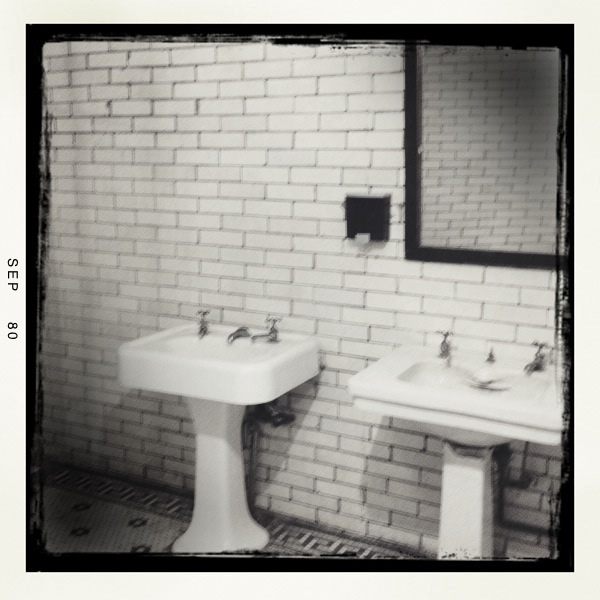Extract all visible text content from this image. SEP 80 